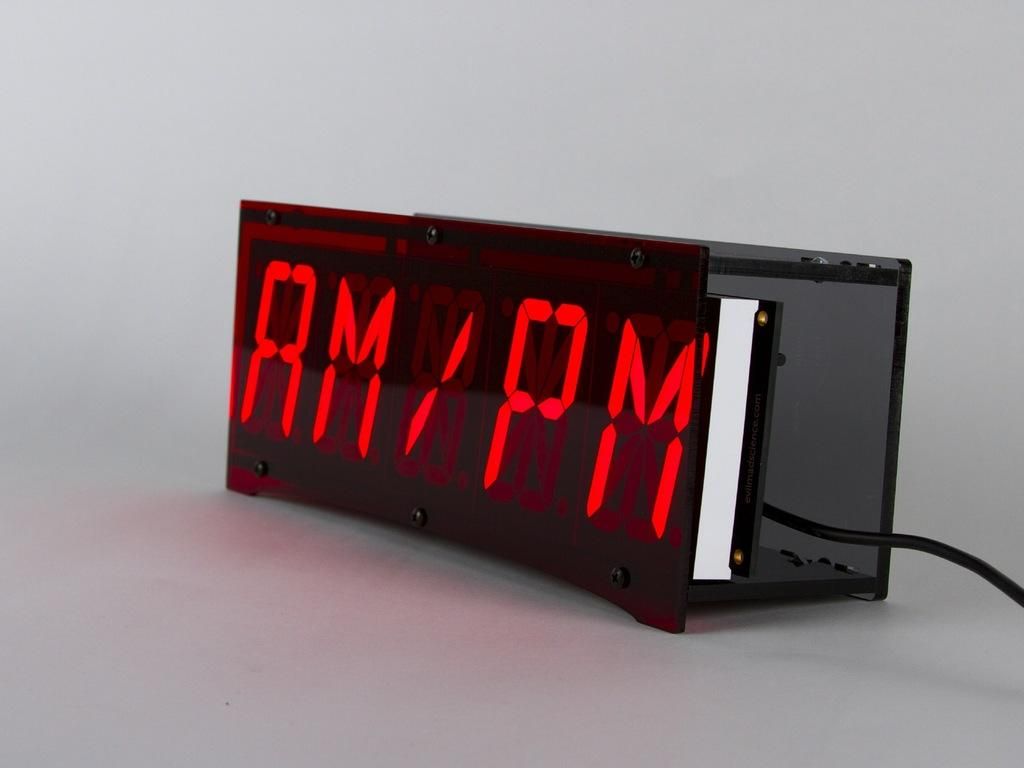What can be seen in the image that displays information? There is a digital display in the image. What is connected to the digital display in the image? There is a cable in the image. What type of bird is sitting on the digital display in the image? There is no bird present in the image; it only features a digital display and a cable. 